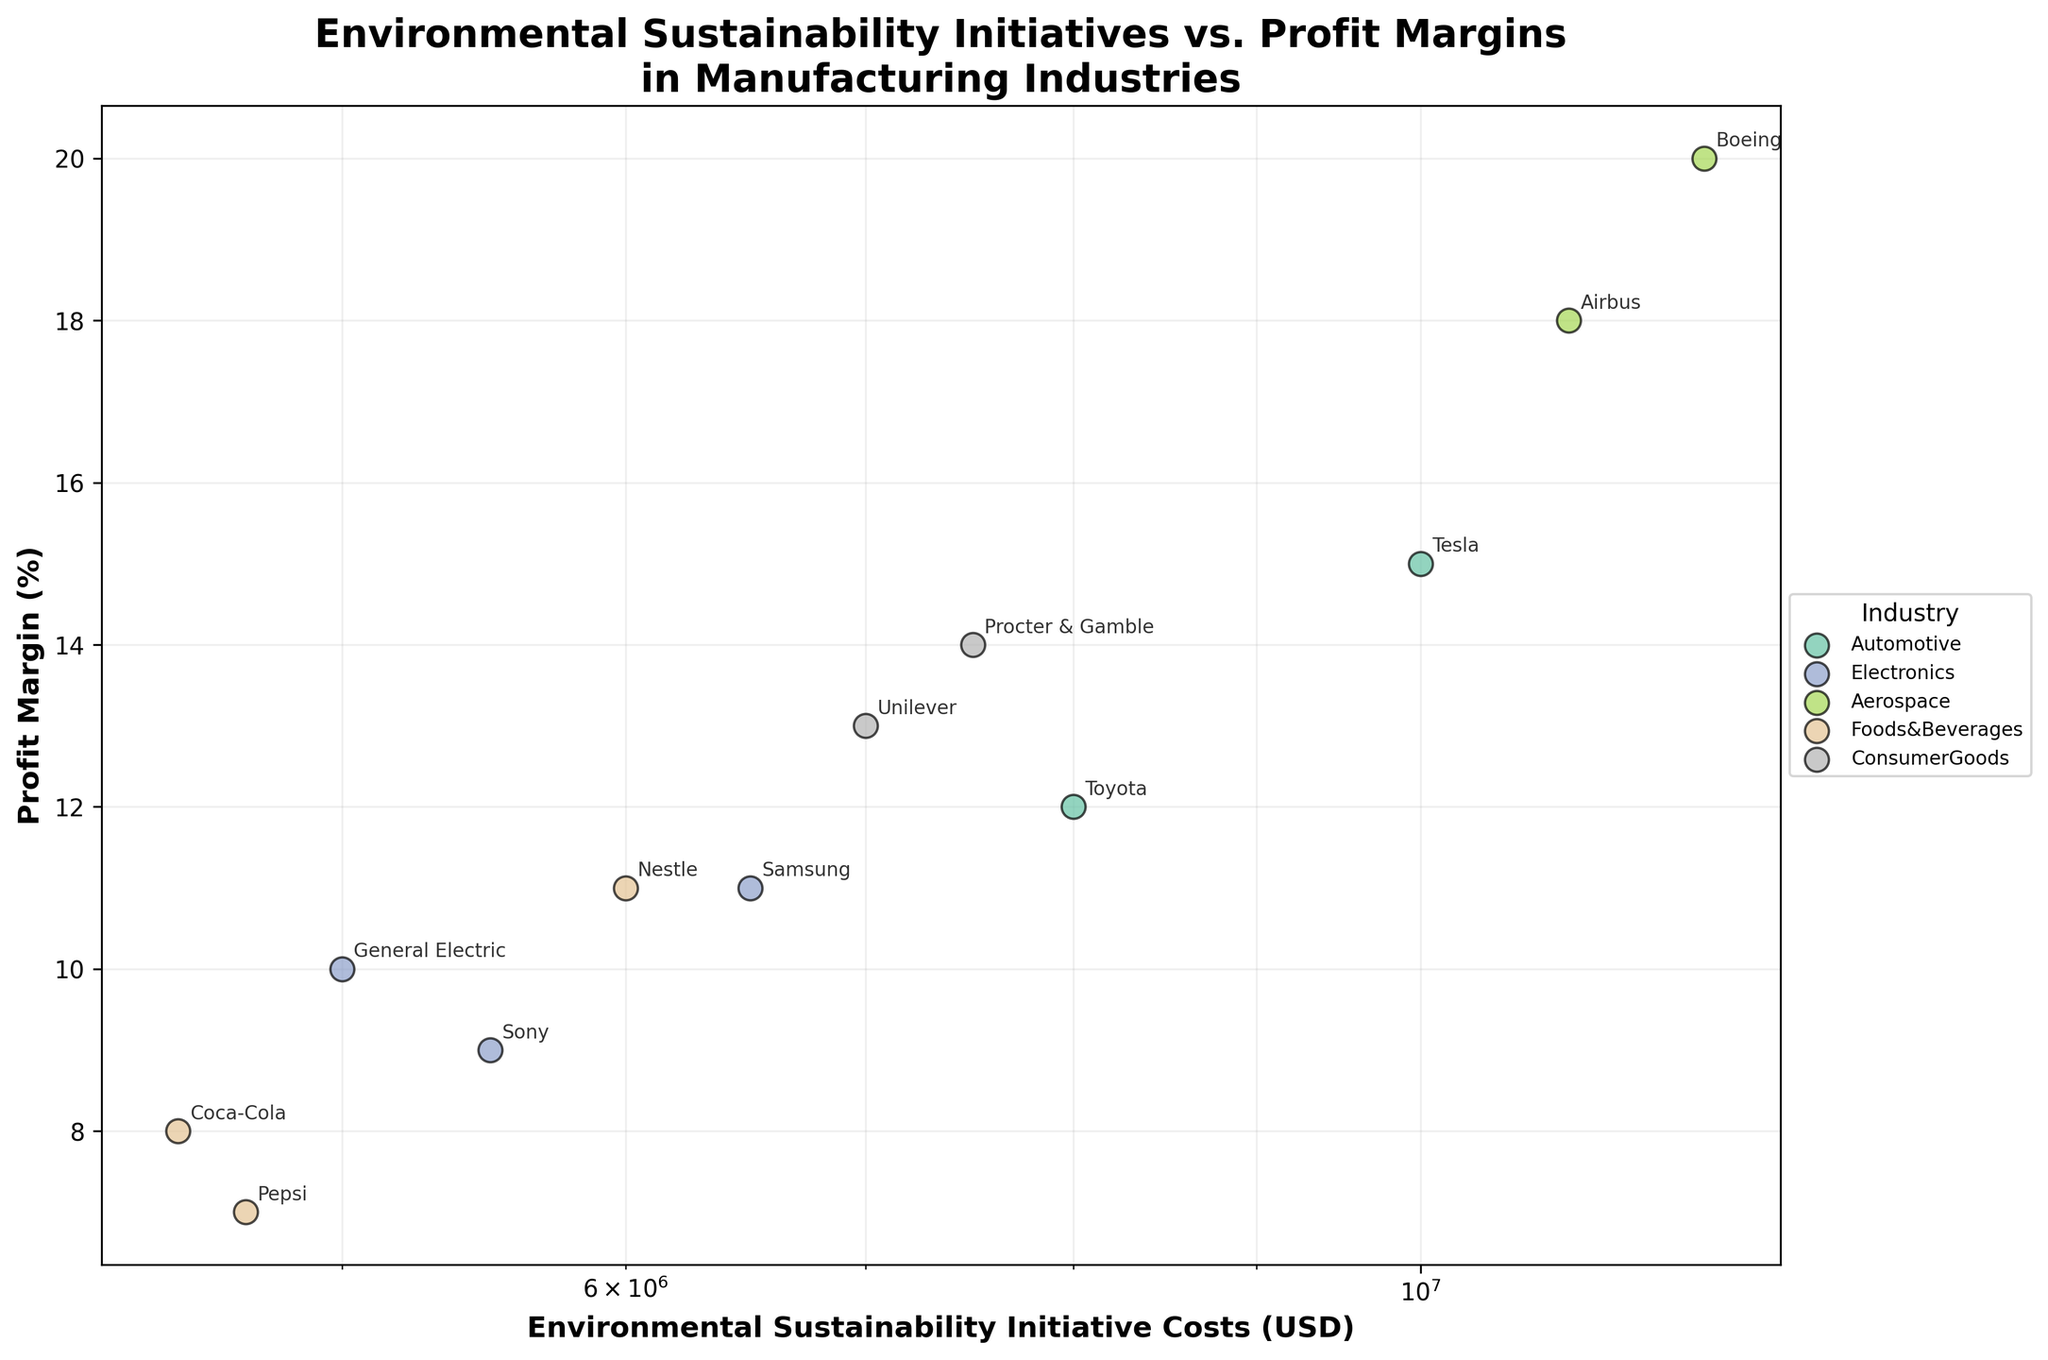What's the title of the figure? The title of the figure appears at the top and describes the main subject of the plot. The exact wording displayed as the title can be read directly from the figure.
Answer: Environmental Sustainability Initiatives vs. Profit Margins in Manufacturing Industries What are the labels of the axes? The x-axis label describes the data represented along the horizontal axis, and the y-axis label describes the data along the vertical axis. By reading these labels, we can understand what each axis measures.
Answer: x-axis: Environmental Sustainability Initiative Costs (USD), y-axis: Profit Margin (%) Which company has the highest profit margin, and what is that value? To find the company with the highest profit margin, look for the point that is positioned furthest up on the vertical axis (y-axis). Then, identify the company associated with this point and note the corresponding profit margin value.
Answer: Boeing, 20% What is the range of Environmental Sustainability Initiative Costs covered in the plot? The range can be determined by identifying the minimum and maximum values on the x-axis (log scale) where data points are plotted.
Answer: $4,500,000 to $12,000,000 Which industry has the most number of companies represented in the figure? Each company is color-coded by industry and listed in the legend. Count the number of companies for each industry to determine which one has the most representations.
Answer: Electronics What's the average profit margin for the Consumer Goods industry? Identify the data points belonging to Consumer Goods, extract each one's profit margin, sum them, and divide by the number of points. For Consumer Goods, the profit margins are 13% and 14%. Calculation: (13 + 14) / 2 = 13.5
Answer: 13.5% How does the profit margin of Unilever compare to Toyota? Locate the data points for Unilever and Toyota on the y-axis to compare their profit margins. Note which company has a higher or lower value.
Answer: Unilever has a higher profit margin (13%) than Toyota (12%) Is there a visible trend between Environmental Sustainability Initiative Costs and Profit Margins? Observe if the data points indicate a general increase, decrease, or no clear pattern between the x and y values. Although there isn't a strong linear trend, higher costs do not strictly correlate with higher profit margins.
Answer: No clear trend Which company has the lowest Environmental Sustainability Initiative Costs, and what is their profit margin? Identify the point located furthest left on the x-axis, corresponding to the lowest cost, and note the company's name and profit margin.
Answer: Coca-Cola, 8% 